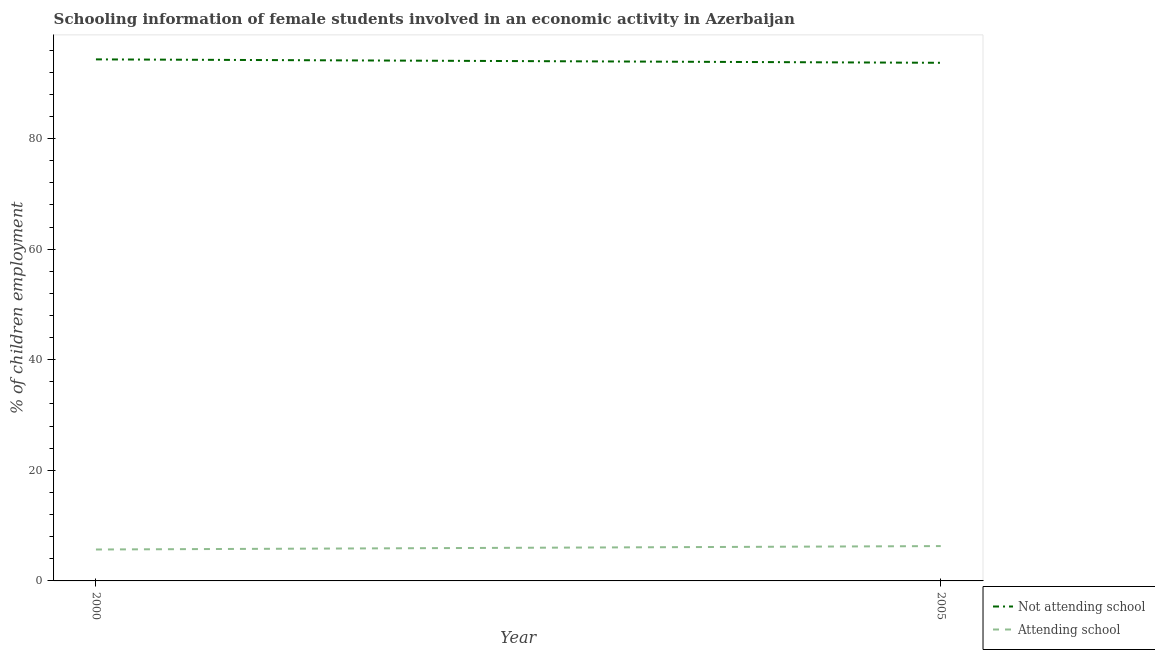Does the line corresponding to percentage of employed females who are not attending school intersect with the line corresponding to percentage of employed females who are attending school?
Give a very brief answer. No. What is the percentage of employed females who are not attending school in 2005?
Ensure brevity in your answer.  93.7. Across all years, what is the maximum percentage of employed females who are not attending school?
Keep it short and to the point. 94.32. Across all years, what is the minimum percentage of employed females who are attending school?
Offer a very short reply. 5.68. What is the total percentage of employed females who are attending school in the graph?
Make the answer very short. 11.98. What is the difference between the percentage of employed females who are attending school in 2000 and that in 2005?
Provide a succinct answer. -0.62. What is the difference between the percentage of employed females who are not attending school in 2005 and the percentage of employed females who are attending school in 2000?
Ensure brevity in your answer.  88.02. What is the average percentage of employed females who are attending school per year?
Your answer should be compact. 5.99. In the year 2000, what is the difference between the percentage of employed females who are attending school and percentage of employed females who are not attending school?
Your answer should be compact. -88.64. What is the ratio of the percentage of employed females who are not attending school in 2000 to that in 2005?
Provide a succinct answer. 1.01. Is the percentage of employed females who are attending school in 2000 less than that in 2005?
Your response must be concise. Yes. In how many years, is the percentage of employed females who are not attending school greater than the average percentage of employed females who are not attending school taken over all years?
Your answer should be compact. 1. Is the percentage of employed females who are not attending school strictly less than the percentage of employed females who are attending school over the years?
Your response must be concise. No. How many years are there in the graph?
Offer a very short reply. 2. What is the difference between two consecutive major ticks on the Y-axis?
Your answer should be very brief. 20. Are the values on the major ticks of Y-axis written in scientific E-notation?
Provide a short and direct response. No. Does the graph contain grids?
Your answer should be very brief. No. How are the legend labels stacked?
Your answer should be very brief. Vertical. What is the title of the graph?
Provide a short and direct response. Schooling information of female students involved in an economic activity in Azerbaijan. What is the label or title of the X-axis?
Your answer should be compact. Year. What is the label or title of the Y-axis?
Your answer should be compact. % of children employment. What is the % of children employment in Not attending school in 2000?
Your answer should be compact. 94.32. What is the % of children employment of Attending school in 2000?
Offer a terse response. 5.68. What is the % of children employment of Not attending school in 2005?
Make the answer very short. 93.7. Across all years, what is the maximum % of children employment of Not attending school?
Provide a succinct answer. 94.32. Across all years, what is the minimum % of children employment of Not attending school?
Make the answer very short. 93.7. Across all years, what is the minimum % of children employment of Attending school?
Your answer should be compact. 5.68. What is the total % of children employment in Not attending school in the graph?
Your answer should be compact. 188.02. What is the total % of children employment of Attending school in the graph?
Keep it short and to the point. 11.98. What is the difference between the % of children employment of Not attending school in 2000 and that in 2005?
Your answer should be compact. 0.62. What is the difference between the % of children employment of Attending school in 2000 and that in 2005?
Offer a very short reply. -0.62. What is the difference between the % of children employment in Not attending school in 2000 and the % of children employment in Attending school in 2005?
Offer a terse response. 88.02. What is the average % of children employment in Not attending school per year?
Offer a terse response. 94.01. What is the average % of children employment in Attending school per year?
Make the answer very short. 5.99. In the year 2000, what is the difference between the % of children employment in Not attending school and % of children employment in Attending school?
Provide a short and direct response. 88.64. In the year 2005, what is the difference between the % of children employment in Not attending school and % of children employment in Attending school?
Make the answer very short. 87.4. What is the ratio of the % of children employment of Not attending school in 2000 to that in 2005?
Your response must be concise. 1.01. What is the ratio of the % of children employment in Attending school in 2000 to that in 2005?
Your answer should be compact. 0.9. What is the difference between the highest and the second highest % of children employment of Not attending school?
Give a very brief answer. 0.62. What is the difference between the highest and the second highest % of children employment in Attending school?
Offer a terse response. 0.62. What is the difference between the highest and the lowest % of children employment of Not attending school?
Offer a terse response. 0.62. What is the difference between the highest and the lowest % of children employment in Attending school?
Your answer should be compact. 0.62. 